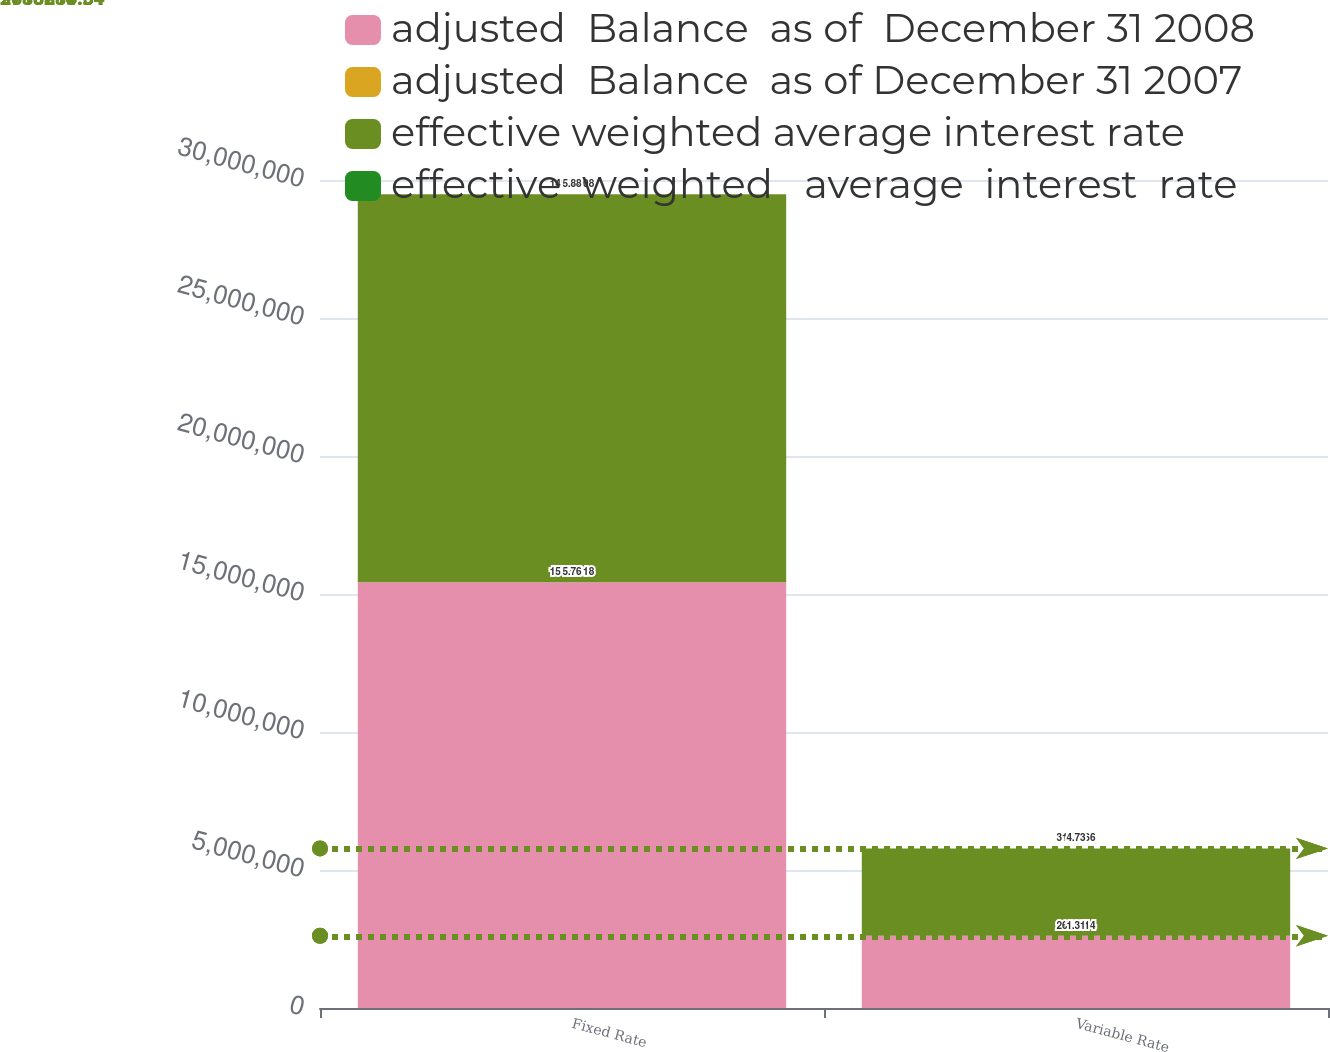<chart> <loc_0><loc_0><loc_500><loc_500><stacked_bar_chart><ecel><fcel>Fixed Rate<fcel>Variable Rate<nl><fcel>adjusted  Balance  as of  December 31 2008<fcel>1.54243e+07<fcel>2.61821e+06<nl><fcel>adjusted  Balance  as of December 31 2007<fcel>5.76<fcel>1.31<nl><fcel>effective weighted average interest rate<fcel>1.4056e+07<fcel>3.16267e+06<nl><fcel>effective  weighted   average  interest  rate<fcel>5.88<fcel>4.73<nl></chart> 